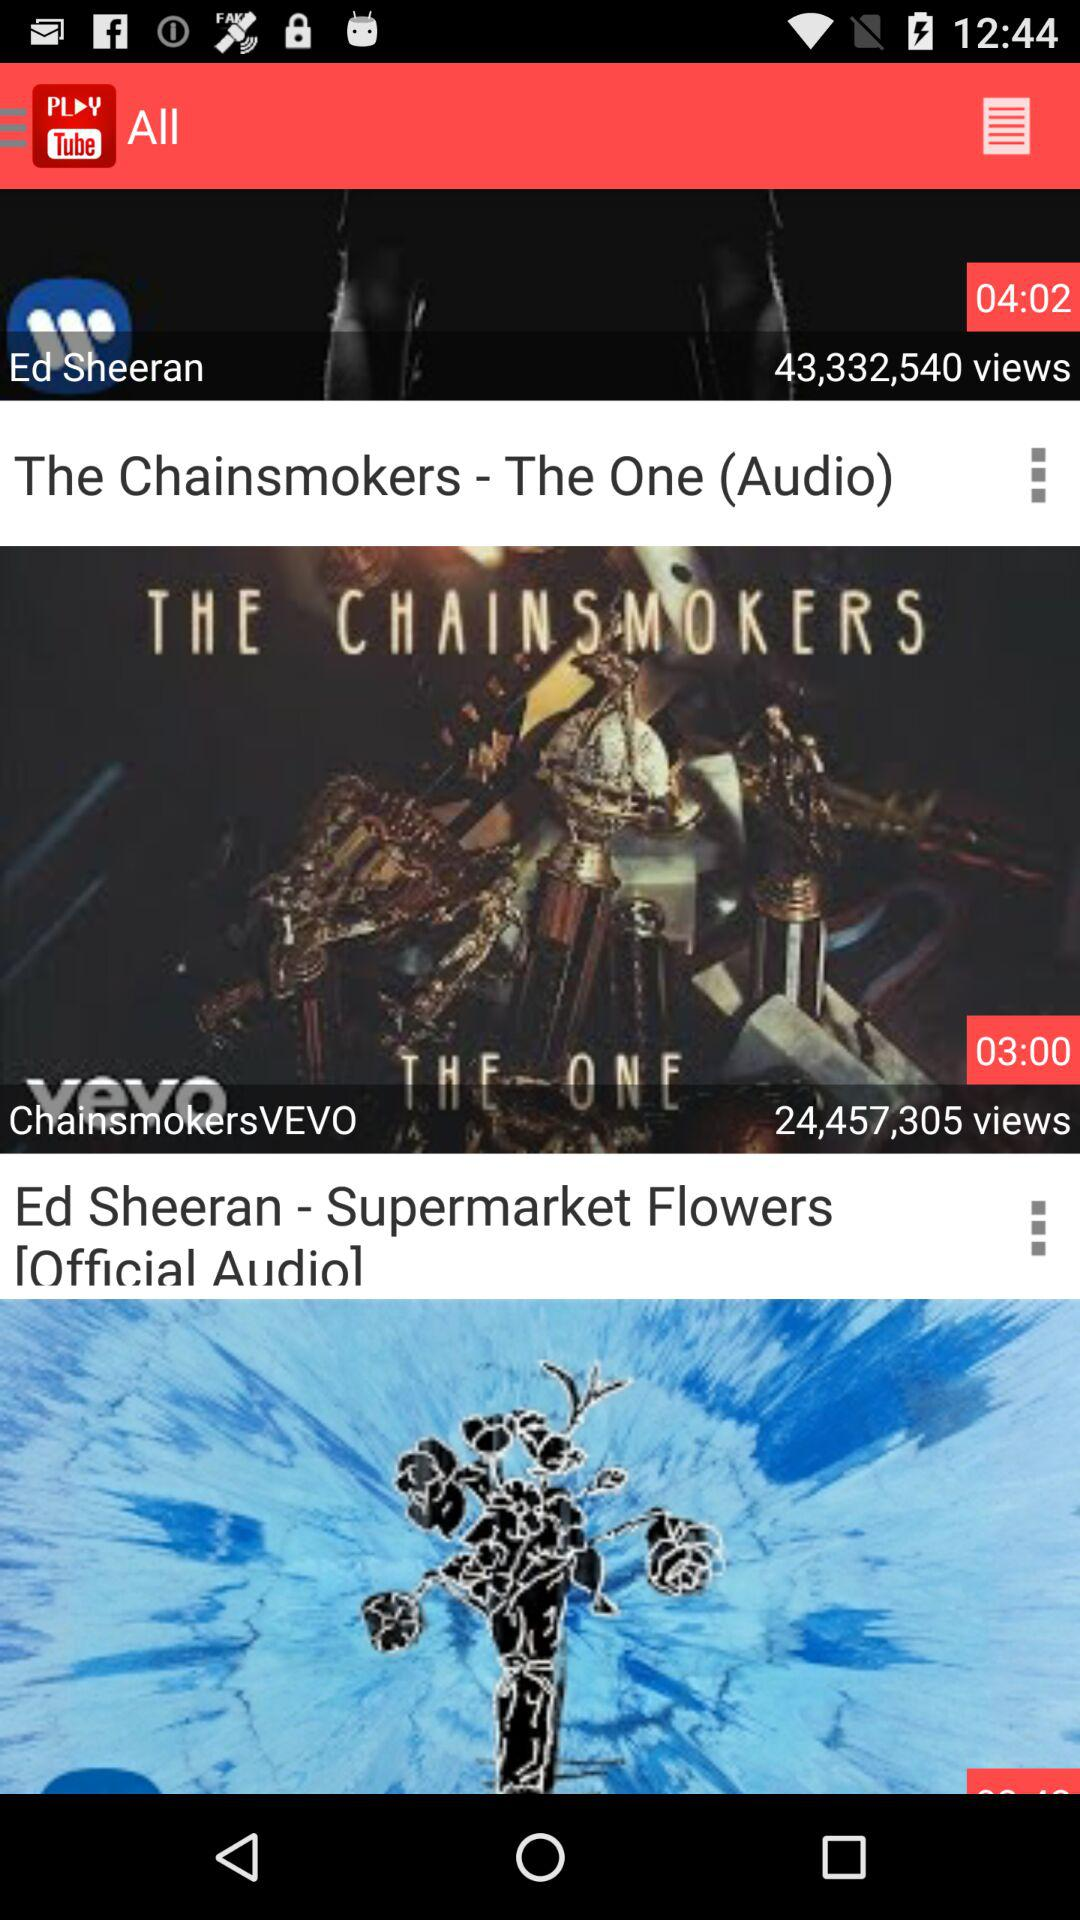What can be inferred about these artists' popularity? Based on the displayed view counts, both artists are highly popular, with each video having tens of millions of views. Is there a way to know the engagement of the audience with these videos? From the image alone, we cannot determine the audience engagement like comments or likes. Normally, you'd have to go to the video's page to assess the engagement metrics. 